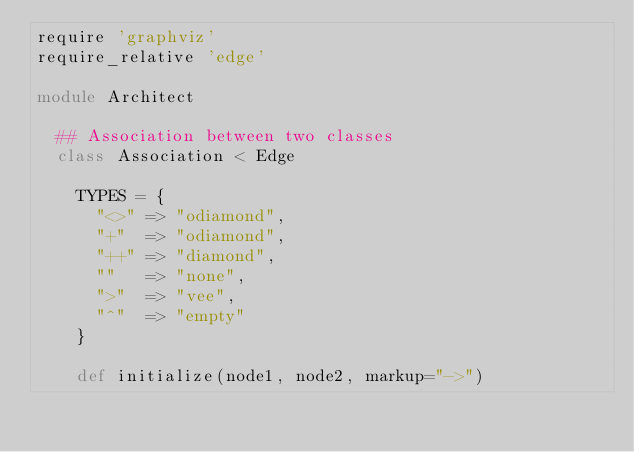<code> <loc_0><loc_0><loc_500><loc_500><_Ruby_>require 'graphviz'
require_relative 'edge'

module Architect
  
  ## Association between two classes
  class Association < Edge
    
    TYPES = {
      "<>" => "odiamond",
      "+"  => "odiamond",
      "++" => "diamond",
      ""   => "none",
      ">"  => "vee",
      "^"  => "empty"
    }
    
    def initialize(node1, node2, markup="->")</code> 